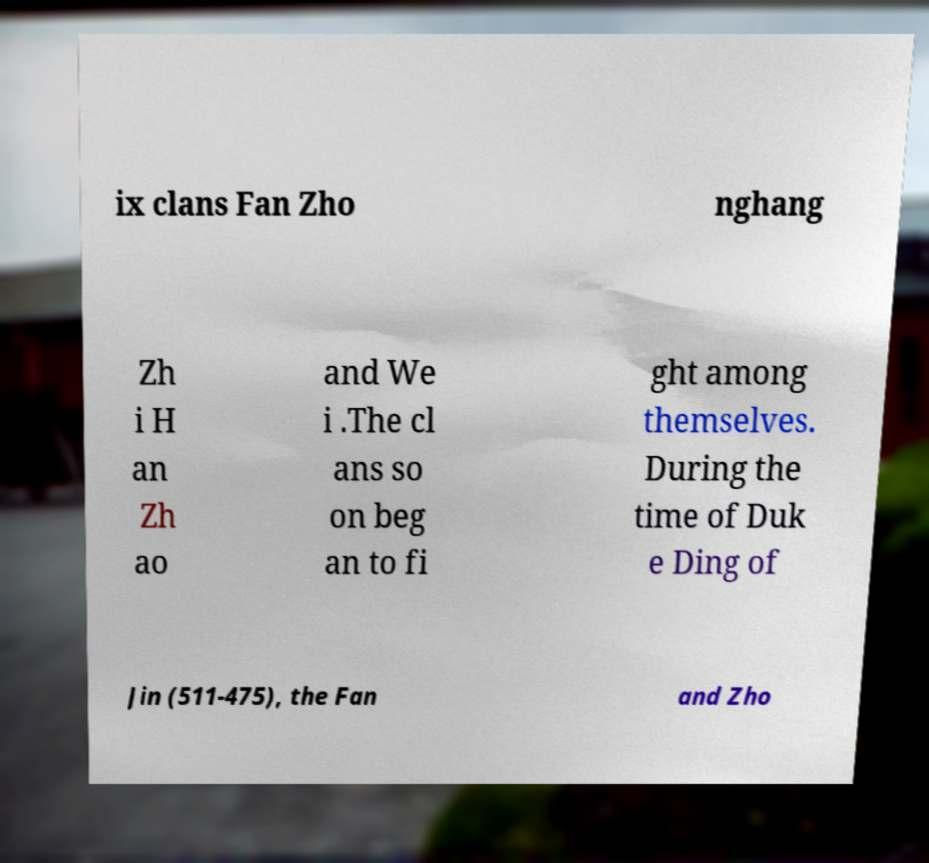What messages or text are displayed in this image? I need them in a readable, typed format. ix clans Fan Zho nghang Zh i H an Zh ao and We i .The cl ans so on beg an to fi ght among themselves. During the time of Duk e Ding of Jin (511-475), the Fan and Zho 